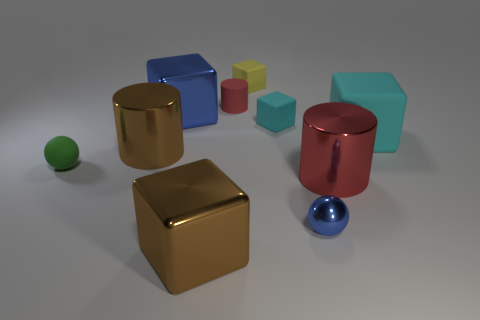How many other shiny objects are the same shape as the big cyan thing?
Keep it short and to the point. 2. What is the size of the sphere that is the same material as the yellow block?
Make the answer very short. Small. What number of brown cylinders are the same size as the blue metallic cube?
Keep it short and to the point. 1. What is the size of the other rubber cube that is the same color as the big rubber block?
Ensure brevity in your answer.  Small. There is a tiny rubber cylinder that is behind the metallic cube that is right of the big blue thing; what is its color?
Keep it short and to the point. Red. Are there any large shiny cubes that have the same color as the large matte cube?
Ensure brevity in your answer.  No. The other metal block that is the same size as the brown metal block is what color?
Your response must be concise. Blue. Do the big thing in front of the tiny shiny object and the small red thing have the same material?
Provide a succinct answer. No. There is a small red thing that is behind the cyan block that is to the left of the big cyan object; are there any red rubber cylinders that are in front of it?
Keep it short and to the point. No. There is a blue metallic thing to the right of the yellow matte object; is it the same shape as the small cyan object?
Provide a short and direct response. No. 